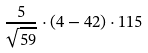<formula> <loc_0><loc_0><loc_500><loc_500>\frac { 5 } { \sqrt { 5 9 } } \cdot ( 4 - 4 2 ) \cdot 1 1 5</formula> 